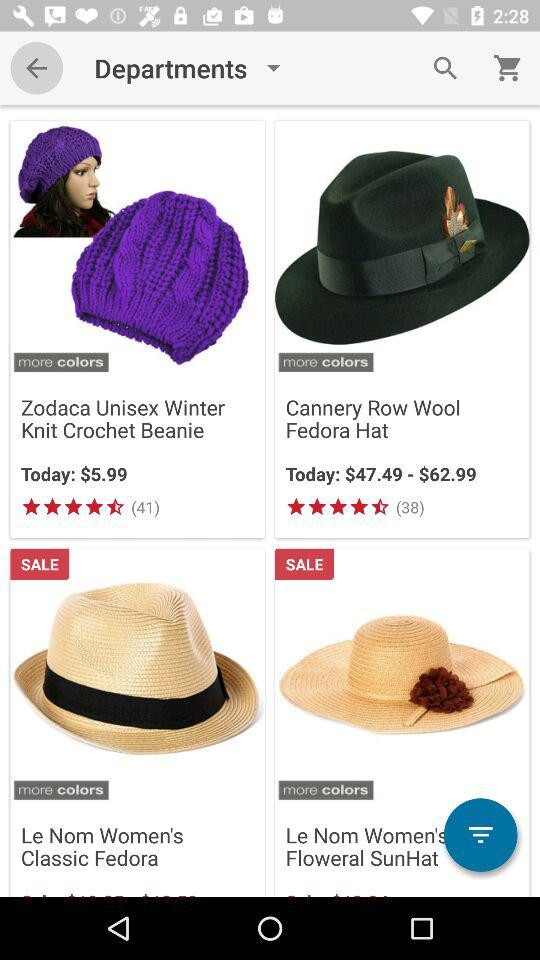How many items are on sale?
Answer the question using a single word or phrase. 2 